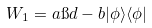<formula> <loc_0><loc_0><loc_500><loc_500>W _ { 1 } = a \i d - b | \phi \rangle \langle \phi |</formula> 